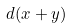<formula> <loc_0><loc_0><loc_500><loc_500>d ( x + y )</formula> 